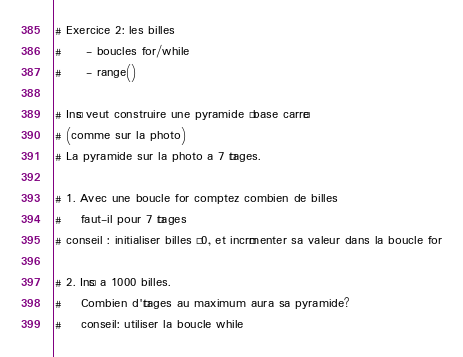<code> <loc_0><loc_0><loc_500><loc_500><_Python_># Exercice 2: les billes
#     - boucles for/while
#     - range()

# Inès veut construire une pyramide à base carrée
# (comme sur la photo)
# La pyramide sur la photo a 7 étages.

# 1. Avec une boucle for comptez combien de billes
#    faut-il pour 7 étages
# conseil : initialiser billes à 0, et incrémenter sa valeur dans la boucle for

# 2. Inès a 1000 billes.
#    Combien d'étages au maximum aura sa pyramide?
#    conseil: utiliser la boucle while  </code> 